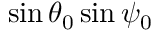Convert formula to latex. <formula><loc_0><loc_0><loc_500><loc_500>\sin \theta _ { 0 } \sin \psi _ { 0 }</formula> 